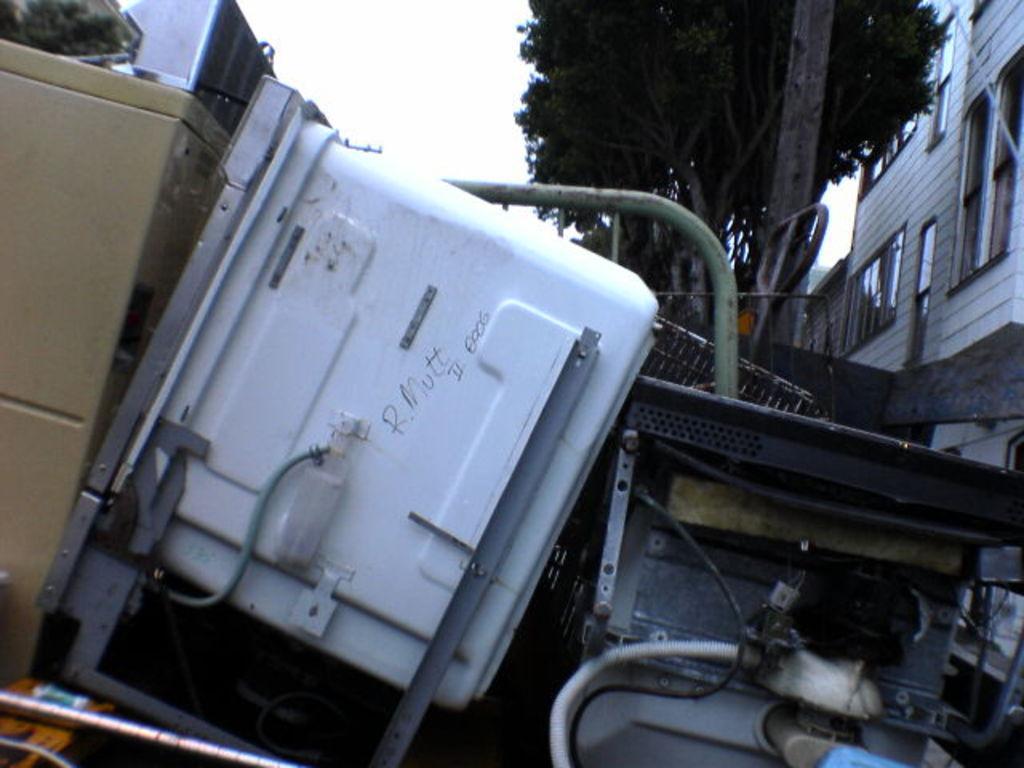Can you describe this image briefly? This image is clicked outside. There is building on the right side. There is a tree at the top. In the middle there is some equipment. 